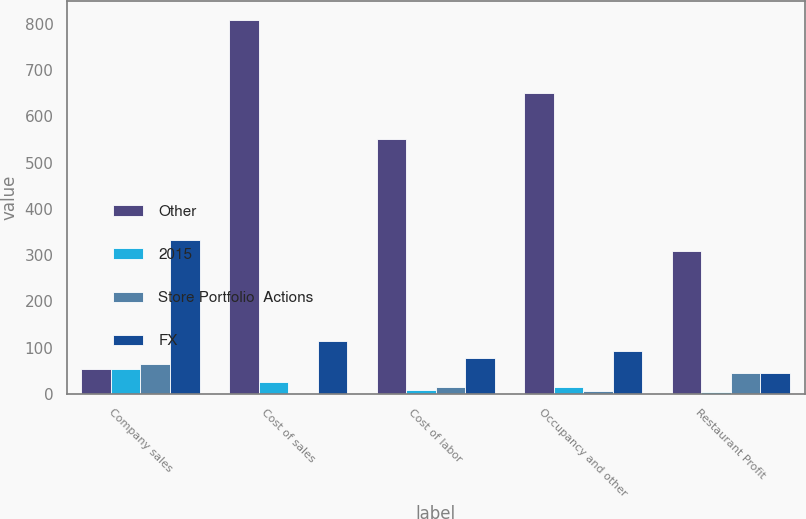<chart> <loc_0><loc_0><loc_500><loc_500><stacked_bar_chart><ecel><fcel>Company sales<fcel>Cost of sales<fcel>Cost of labor<fcel>Occupancy and other<fcel>Restaurant Profit<nl><fcel>Other<fcel>54<fcel>809<fcel>552<fcel>651<fcel>308<nl><fcel>2015<fcel>54<fcel>25<fcel>8<fcel>16<fcel>5<nl><fcel>Store Portfolio  Actions<fcel>65<fcel>2<fcel>16<fcel>6<fcel>45<nl><fcel>FX<fcel>333<fcel>115<fcel>79<fcel>93<fcel>46<nl></chart> 